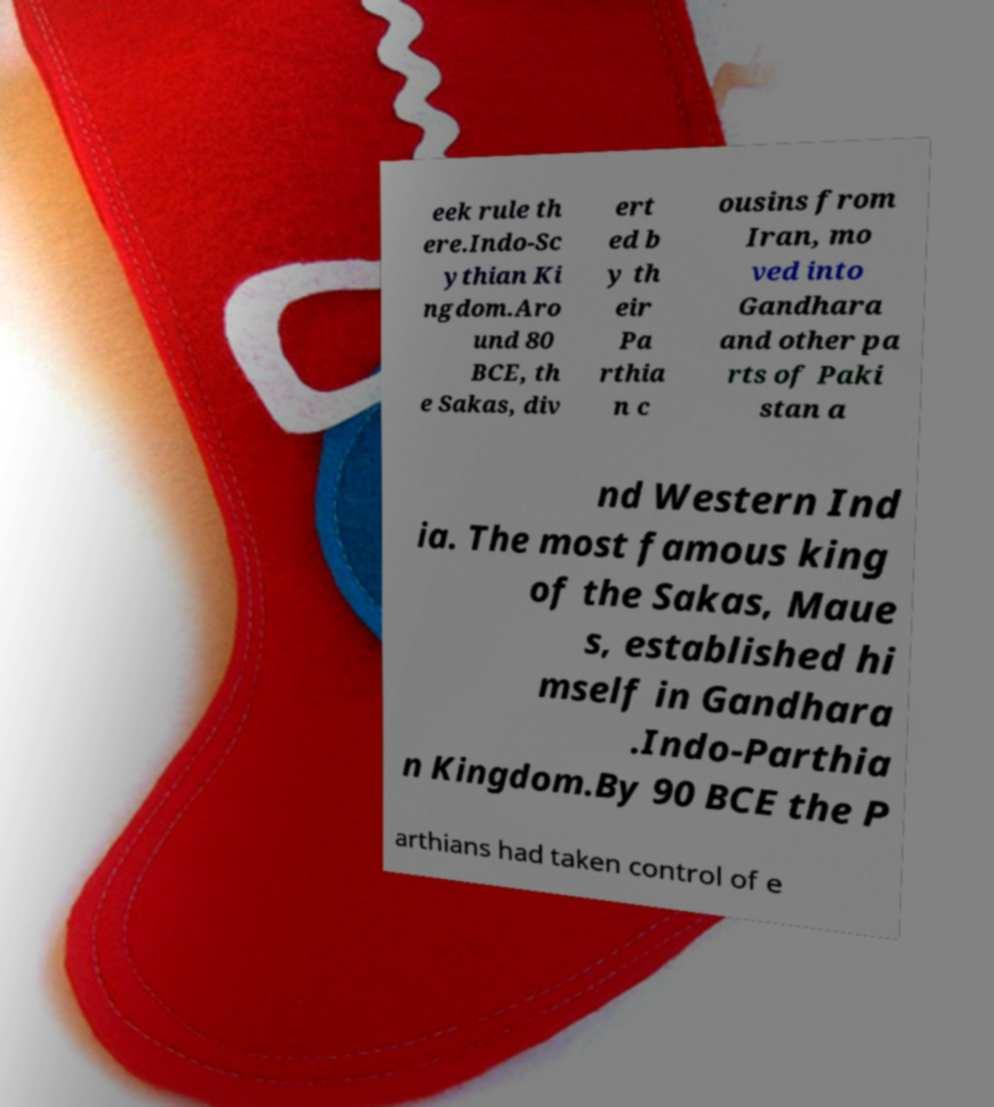I need the written content from this picture converted into text. Can you do that? eek rule th ere.Indo-Sc ythian Ki ngdom.Aro und 80 BCE, th e Sakas, div ert ed b y th eir Pa rthia n c ousins from Iran, mo ved into Gandhara and other pa rts of Paki stan a nd Western Ind ia. The most famous king of the Sakas, Maue s, established hi mself in Gandhara .Indo-Parthia n Kingdom.By 90 BCE the P arthians had taken control of e 